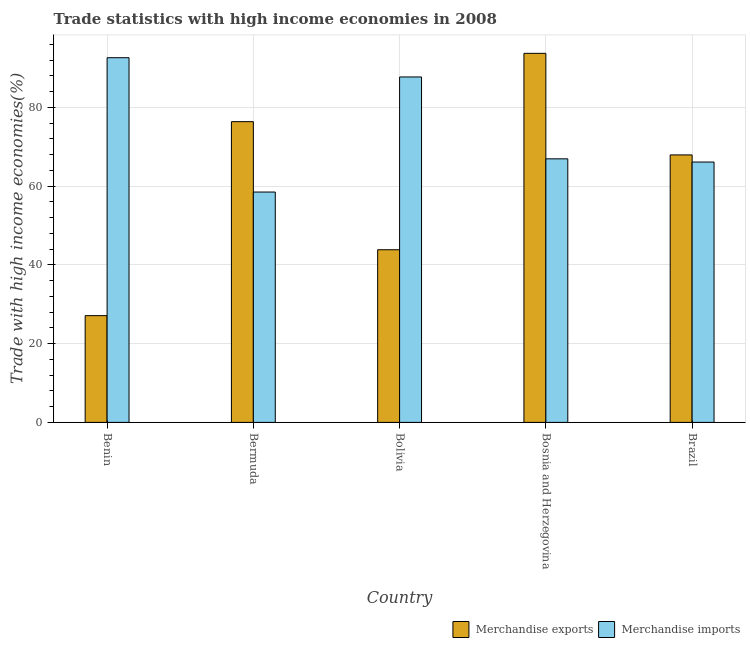How many groups of bars are there?
Ensure brevity in your answer.  5. How many bars are there on the 2nd tick from the left?
Your answer should be very brief. 2. What is the label of the 5th group of bars from the left?
Provide a short and direct response. Brazil. In how many cases, is the number of bars for a given country not equal to the number of legend labels?
Your answer should be very brief. 0. What is the merchandise exports in Brazil?
Provide a short and direct response. 67.94. Across all countries, what is the maximum merchandise imports?
Provide a short and direct response. 92.63. Across all countries, what is the minimum merchandise imports?
Offer a terse response. 58.51. In which country was the merchandise imports maximum?
Give a very brief answer. Benin. In which country was the merchandise exports minimum?
Ensure brevity in your answer.  Benin. What is the total merchandise imports in the graph?
Offer a very short reply. 371.95. What is the difference between the merchandise imports in Bermuda and that in Bolivia?
Ensure brevity in your answer.  -29.23. What is the difference between the merchandise exports in Brazil and the merchandise imports in Benin?
Your response must be concise. -24.69. What is the average merchandise imports per country?
Offer a terse response. 74.39. What is the difference between the merchandise imports and merchandise exports in Bolivia?
Give a very brief answer. 43.88. What is the ratio of the merchandise exports in Bermuda to that in Brazil?
Offer a very short reply. 1.12. Is the merchandise exports in Bolivia less than that in Bosnia and Herzegovina?
Offer a terse response. Yes. What is the difference between the highest and the second highest merchandise imports?
Your answer should be compact. 4.89. What is the difference between the highest and the lowest merchandise imports?
Ensure brevity in your answer.  34.12. In how many countries, is the merchandise exports greater than the average merchandise exports taken over all countries?
Your answer should be very brief. 3. Are all the bars in the graph horizontal?
Keep it short and to the point. No. How many countries are there in the graph?
Make the answer very short. 5. Are the values on the major ticks of Y-axis written in scientific E-notation?
Keep it short and to the point. No. Does the graph contain any zero values?
Keep it short and to the point. No. Does the graph contain grids?
Provide a succinct answer. Yes. What is the title of the graph?
Provide a succinct answer. Trade statistics with high income economies in 2008. Does "constant 2005 US$" appear as one of the legend labels in the graph?
Your response must be concise. No. What is the label or title of the X-axis?
Offer a very short reply. Country. What is the label or title of the Y-axis?
Provide a short and direct response. Trade with high income economies(%). What is the Trade with high income economies(%) in Merchandise exports in Benin?
Give a very brief answer. 27.11. What is the Trade with high income economies(%) of Merchandise imports in Benin?
Provide a short and direct response. 92.63. What is the Trade with high income economies(%) in Merchandise exports in Bermuda?
Provide a short and direct response. 76.38. What is the Trade with high income economies(%) of Merchandise imports in Bermuda?
Offer a very short reply. 58.51. What is the Trade with high income economies(%) in Merchandise exports in Bolivia?
Your answer should be compact. 43.85. What is the Trade with high income economies(%) in Merchandise imports in Bolivia?
Ensure brevity in your answer.  87.74. What is the Trade with high income economies(%) of Merchandise exports in Bosnia and Herzegovina?
Give a very brief answer. 93.74. What is the Trade with high income economies(%) in Merchandise imports in Bosnia and Herzegovina?
Ensure brevity in your answer.  66.94. What is the Trade with high income economies(%) of Merchandise exports in Brazil?
Keep it short and to the point. 67.94. What is the Trade with high income economies(%) in Merchandise imports in Brazil?
Offer a very short reply. 66.13. Across all countries, what is the maximum Trade with high income economies(%) of Merchandise exports?
Provide a short and direct response. 93.74. Across all countries, what is the maximum Trade with high income economies(%) of Merchandise imports?
Provide a succinct answer. 92.63. Across all countries, what is the minimum Trade with high income economies(%) of Merchandise exports?
Make the answer very short. 27.11. Across all countries, what is the minimum Trade with high income economies(%) in Merchandise imports?
Your response must be concise. 58.51. What is the total Trade with high income economies(%) in Merchandise exports in the graph?
Offer a terse response. 309.03. What is the total Trade with high income economies(%) of Merchandise imports in the graph?
Make the answer very short. 371.95. What is the difference between the Trade with high income economies(%) in Merchandise exports in Benin and that in Bermuda?
Offer a very short reply. -49.27. What is the difference between the Trade with high income economies(%) in Merchandise imports in Benin and that in Bermuda?
Offer a very short reply. 34.12. What is the difference between the Trade with high income economies(%) of Merchandise exports in Benin and that in Bolivia?
Make the answer very short. -16.74. What is the difference between the Trade with high income economies(%) in Merchandise imports in Benin and that in Bolivia?
Your answer should be very brief. 4.89. What is the difference between the Trade with high income economies(%) of Merchandise exports in Benin and that in Bosnia and Herzegovina?
Provide a short and direct response. -66.63. What is the difference between the Trade with high income economies(%) of Merchandise imports in Benin and that in Bosnia and Herzegovina?
Your response must be concise. 25.68. What is the difference between the Trade with high income economies(%) in Merchandise exports in Benin and that in Brazil?
Offer a very short reply. -40.83. What is the difference between the Trade with high income economies(%) of Merchandise imports in Benin and that in Brazil?
Your answer should be compact. 26.5. What is the difference between the Trade with high income economies(%) of Merchandise exports in Bermuda and that in Bolivia?
Your answer should be very brief. 32.53. What is the difference between the Trade with high income economies(%) in Merchandise imports in Bermuda and that in Bolivia?
Make the answer very short. -29.23. What is the difference between the Trade with high income economies(%) in Merchandise exports in Bermuda and that in Bosnia and Herzegovina?
Make the answer very short. -17.36. What is the difference between the Trade with high income economies(%) in Merchandise imports in Bermuda and that in Bosnia and Herzegovina?
Ensure brevity in your answer.  -8.43. What is the difference between the Trade with high income economies(%) in Merchandise exports in Bermuda and that in Brazil?
Give a very brief answer. 8.44. What is the difference between the Trade with high income economies(%) of Merchandise imports in Bermuda and that in Brazil?
Offer a very short reply. -7.62. What is the difference between the Trade with high income economies(%) of Merchandise exports in Bolivia and that in Bosnia and Herzegovina?
Provide a short and direct response. -49.89. What is the difference between the Trade with high income economies(%) in Merchandise imports in Bolivia and that in Bosnia and Herzegovina?
Give a very brief answer. 20.8. What is the difference between the Trade with high income economies(%) of Merchandise exports in Bolivia and that in Brazil?
Offer a very short reply. -24.09. What is the difference between the Trade with high income economies(%) in Merchandise imports in Bolivia and that in Brazil?
Give a very brief answer. 21.61. What is the difference between the Trade with high income economies(%) of Merchandise exports in Bosnia and Herzegovina and that in Brazil?
Keep it short and to the point. 25.8. What is the difference between the Trade with high income economies(%) of Merchandise imports in Bosnia and Herzegovina and that in Brazil?
Offer a very short reply. 0.81. What is the difference between the Trade with high income economies(%) of Merchandise exports in Benin and the Trade with high income economies(%) of Merchandise imports in Bermuda?
Offer a very short reply. -31.4. What is the difference between the Trade with high income economies(%) in Merchandise exports in Benin and the Trade with high income economies(%) in Merchandise imports in Bolivia?
Offer a very short reply. -60.63. What is the difference between the Trade with high income economies(%) in Merchandise exports in Benin and the Trade with high income economies(%) in Merchandise imports in Bosnia and Herzegovina?
Offer a terse response. -39.83. What is the difference between the Trade with high income economies(%) in Merchandise exports in Benin and the Trade with high income economies(%) in Merchandise imports in Brazil?
Offer a terse response. -39.02. What is the difference between the Trade with high income economies(%) in Merchandise exports in Bermuda and the Trade with high income economies(%) in Merchandise imports in Bolivia?
Keep it short and to the point. -11.35. What is the difference between the Trade with high income economies(%) of Merchandise exports in Bermuda and the Trade with high income economies(%) of Merchandise imports in Bosnia and Herzegovina?
Your answer should be compact. 9.44. What is the difference between the Trade with high income economies(%) of Merchandise exports in Bermuda and the Trade with high income economies(%) of Merchandise imports in Brazil?
Ensure brevity in your answer.  10.25. What is the difference between the Trade with high income economies(%) of Merchandise exports in Bolivia and the Trade with high income economies(%) of Merchandise imports in Bosnia and Herzegovina?
Ensure brevity in your answer.  -23.09. What is the difference between the Trade with high income economies(%) of Merchandise exports in Bolivia and the Trade with high income economies(%) of Merchandise imports in Brazil?
Offer a very short reply. -22.28. What is the difference between the Trade with high income economies(%) in Merchandise exports in Bosnia and Herzegovina and the Trade with high income economies(%) in Merchandise imports in Brazil?
Your answer should be compact. 27.61. What is the average Trade with high income economies(%) of Merchandise exports per country?
Offer a terse response. 61.81. What is the average Trade with high income economies(%) in Merchandise imports per country?
Offer a very short reply. 74.39. What is the difference between the Trade with high income economies(%) in Merchandise exports and Trade with high income economies(%) in Merchandise imports in Benin?
Offer a terse response. -65.52. What is the difference between the Trade with high income economies(%) in Merchandise exports and Trade with high income economies(%) in Merchandise imports in Bermuda?
Offer a terse response. 17.87. What is the difference between the Trade with high income economies(%) in Merchandise exports and Trade with high income economies(%) in Merchandise imports in Bolivia?
Make the answer very short. -43.88. What is the difference between the Trade with high income economies(%) of Merchandise exports and Trade with high income economies(%) of Merchandise imports in Bosnia and Herzegovina?
Provide a short and direct response. 26.8. What is the difference between the Trade with high income economies(%) in Merchandise exports and Trade with high income economies(%) in Merchandise imports in Brazil?
Ensure brevity in your answer.  1.81. What is the ratio of the Trade with high income economies(%) of Merchandise exports in Benin to that in Bermuda?
Provide a short and direct response. 0.35. What is the ratio of the Trade with high income economies(%) of Merchandise imports in Benin to that in Bermuda?
Your response must be concise. 1.58. What is the ratio of the Trade with high income economies(%) of Merchandise exports in Benin to that in Bolivia?
Provide a short and direct response. 0.62. What is the ratio of the Trade with high income economies(%) of Merchandise imports in Benin to that in Bolivia?
Give a very brief answer. 1.06. What is the ratio of the Trade with high income economies(%) of Merchandise exports in Benin to that in Bosnia and Herzegovina?
Your answer should be very brief. 0.29. What is the ratio of the Trade with high income economies(%) of Merchandise imports in Benin to that in Bosnia and Herzegovina?
Provide a succinct answer. 1.38. What is the ratio of the Trade with high income economies(%) in Merchandise exports in Benin to that in Brazil?
Keep it short and to the point. 0.4. What is the ratio of the Trade with high income economies(%) of Merchandise imports in Benin to that in Brazil?
Your answer should be very brief. 1.4. What is the ratio of the Trade with high income economies(%) of Merchandise exports in Bermuda to that in Bolivia?
Offer a very short reply. 1.74. What is the ratio of the Trade with high income economies(%) in Merchandise imports in Bermuda to that in Bolivia?
Your answer should be very brief. 0.67. What is the ratio of the Trade with high income economies(%) of Merchandise exports in Bermuda to that in Bosnia and Herzegovina?
Provide a short and direct response. 0.81. What is the ratio of the Trade with high income economies(%) in Merchandise imports in Bermuda to that in Bosnia and Herzegovina?
Your answer should be very brief. 0.87. What is the ratio of the Trade with high income economies(%) in Merchandise exports in Bermuda to that in Brazil?
Give a very brief answer. 1.12. What is the ratio of the Trade with high income economies(%) in Merchandise imports in Bermuda to that in Brazil?
Your answer should be compact. 0.88. What is the ratio of the Trade with high income economies(%) of Merchandise exports in Bolivia to that in Bosnia and Herzegovina?
Ensure brevity in your answer.  0.47. What is the ratio of the Trade with high income economies(%) of Merchandise imports in Bolivia to that in Bosnia and Herzegovina?
Offer a terse response. 1.31. What is the ratio of the Trade with high income economies(%) in Merchandise exports in Bolivia to that in Brazil?
Offer a terse response. 0.65. What is the ratio of the Trade with high income economies(%) in Merchandise imports in Bolivia to that in Brazil?
Keep it short and to the point. 1.33. What is the ratio of the Trade with high income economies(%) in Merchandise exports in Bosnia and Herzegovina to that in Brazil?
Give a very brief answer. 1.38. What is the ratio of the Trade with high income economies(%) of Merchandise imports in Bosnia and Herzegovina to that in Brazil?
Provide a succinct answer. 1.01. What is the difference between the highest and the second highest Trade with high income economies(%) in Merchandise exports?
Provide a short and direct response. 17.36. What is the difference between the highest and the second highest Trade with high income economies(%) in Merchandise imports?
Ensure brevity in your answer.  4.89. What is the difference between the highest and the lowest Trade with high income economies(%) in Merchandise exports?
Provide a short and direct response. 66.63. What is the difference between the highest and the lowest Trade with high income economies(%) of Merchandise imports?
Your answer should be compact. 34.12. 